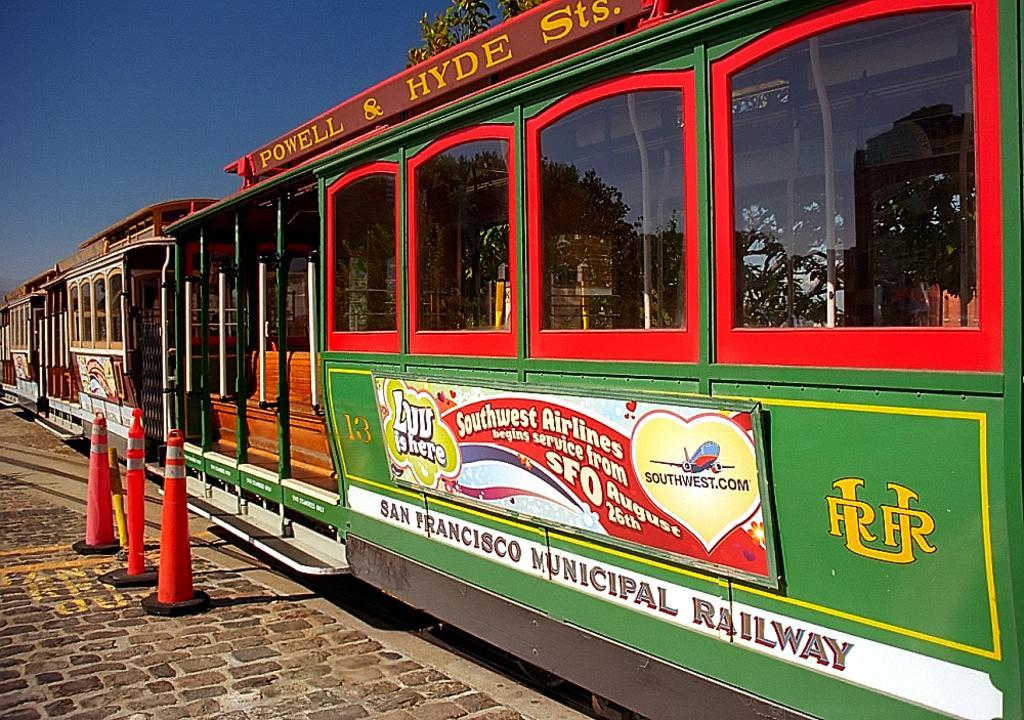Describe this image in one or two sentences. In the image we can see the train and these are the windows of the train. Here we can see the road cone, footpath, leaves and the sky. 